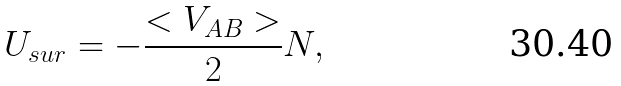Convert formula to latex. <formula><loc_0><loc_0><loc_500><loc_500>U _ { s u r } = - \frac { < V _ { A B } > } { 2 } N ,</formula> 